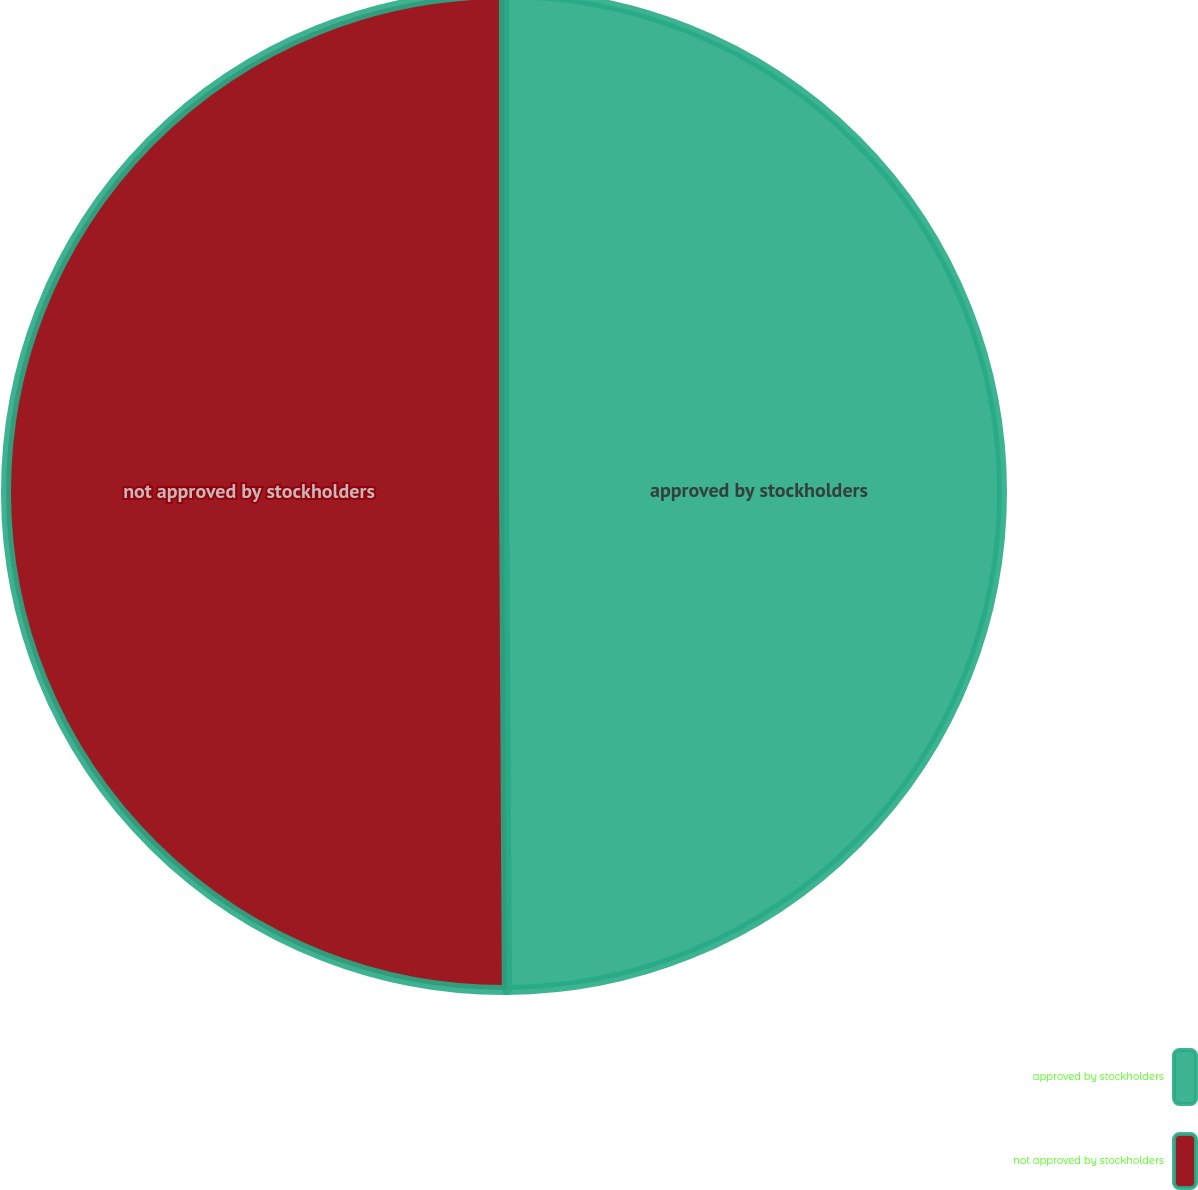Convert chart. <chart><loc_0><loc_0><loc_500><loc_500><pie_chart><fcel>approved by stockholders<fcel>not approved by stockholders<nl><fcel>49.91%<fcel>50.09%<nl></chart> 